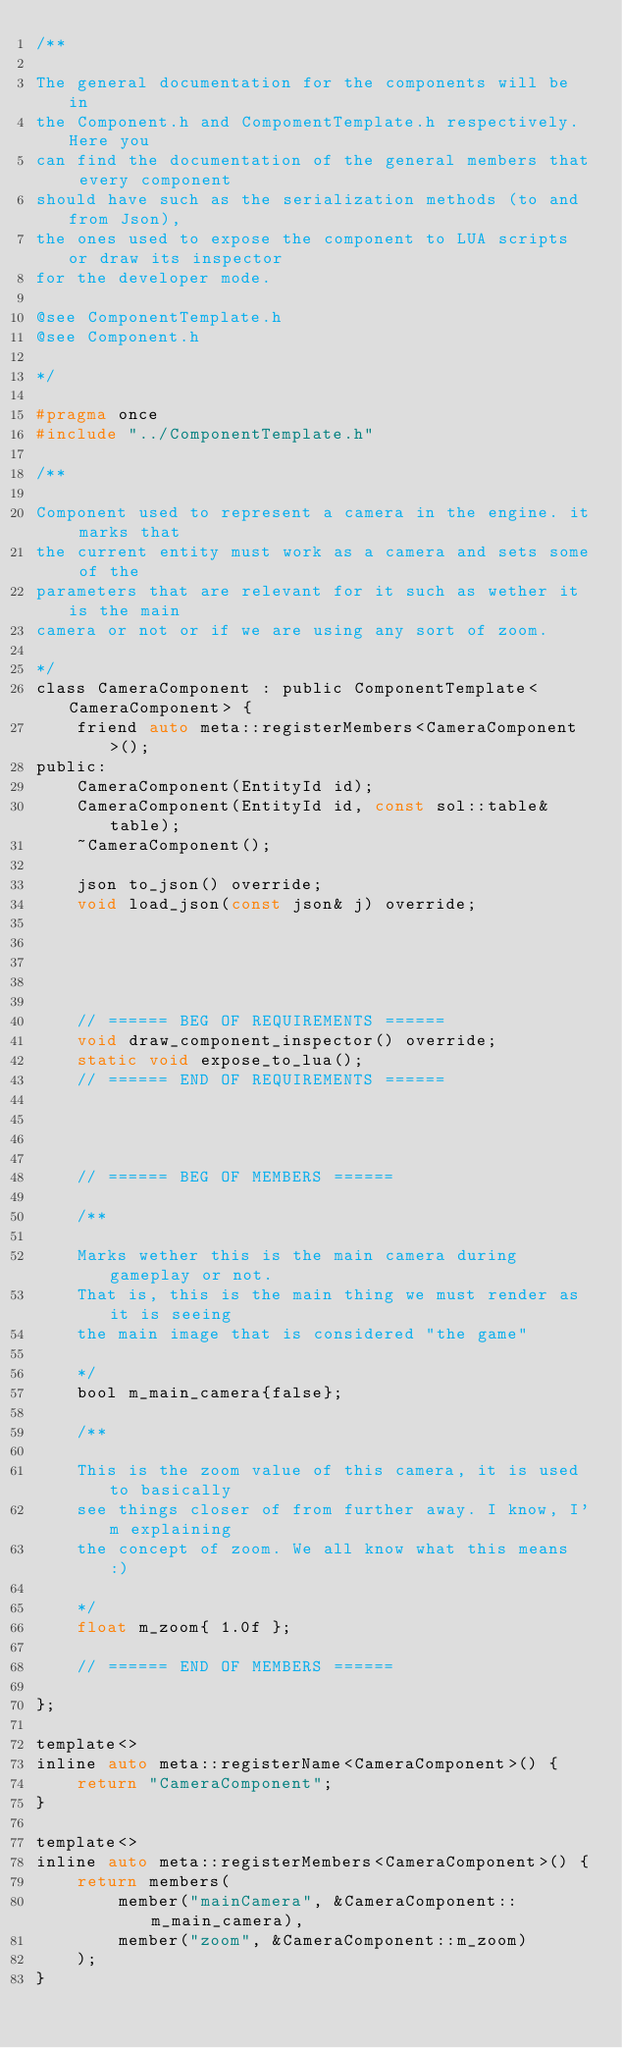Convert code to text. <code><loc_0><loc_0><loc_500><loc_500><_C_>/**

The general documentation for the components will be in
the Component.h and CompomentTemplate.h respectively. Here you
can find the documentation of the general members that every component
should have such as the serialization methods (to and from Json),
the ones used to expose the component to LUA scripts or draw its inspector
for the developer mode.

@see ComponentTemplate.h
@see Component.h

*/

#pragma once
#include "../ComponentTemplate.h"

/**

Component used to represent a camera in the engine. it marks that
the current entity must work as a camera and sets some of the
parameters that are relevant for it such as wether it is the main
camera or not or if we are using any sort of zoom.

*/
class CameraComponent : public ComponentTemplate<CameraComponent> {
    friend auto meta::registerMembers<CameraComponent>();
public:
    CameraComponent(EntityId id);
    CameraComponent(EntityId id, const sol::table& table);
    ~CameraComponent();

    json to_json() override;
    void load_json(const json& j) override;





    // ====== BEG OF REQUIREMENTS ======
    void draw_component_inspector() override;
    static void expose_to_lua();  
    // ====== END OF REQUIREMENTS ======



    
    // ====== BEG OF MEMBERS ======

    /**
    
    Marks wether this is the main camera during gameplay or not.
    That is, this is the main thing we must render as it is seeing
    the main image that is considered "the game"
    
    */
    bool m_main_camera{false};

    /**
    
    This is the zoom value of this camera, it is used to basically
    see things closer of from further away. I know, I'm explaining
    the concept of zoom. We all know what this means :)
    
    */
    float m_zoom{ 1.0f };

    // ====== END OF MEMBERS ======

};

template<>
inline auto meta::registerName<CameraComponent>() {
    return "CameraComponent";
}

template<>
inline auto meta::registerMembers<CameraComponent>() {
    return members(
        member("mainCamera", &CameraComponent::m_main_camera),
        member("zoom", &CameraComponent::m_zoom)
    );
}


</code> 